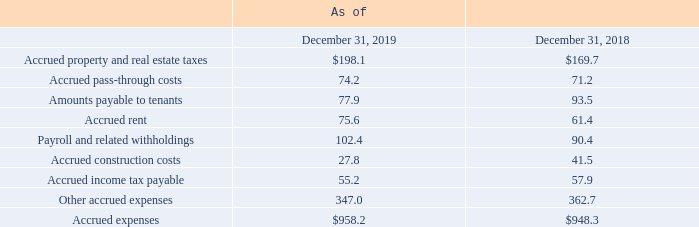AMERICAN TOWER CORPORATION AND SUBSIDIARIES NOTES TO CONSOLIDATED FINANCIAL STATEMENTS (Tabular amounts in millions, unless otherwise disclosed)
8. ACCRUED EXPENSES
Accrued expenses consisted of the following:
What was the Accrued property and real estate taxes in 2018?
Answer scale should be: million. $169.7. What was the Accrued pass-through costs in 2018?
Answer scale should be: million. 71.2. What were the Accrued expenses in 2019?
Answer scale should be: million. $958.2. What was the change in Other accrued expenses between 2018 and 2019?
Answer scale should be: million. 347.0-362.7
Answer: -15.7. What is the sum of the three highest expenses in 2019?
Answer scale should be: million. 198.1+102.4+ 347.0 
Answer: 647.5. What was the percentage change in accrued expenses between 2018 and 2019?
Answer scale should be: percent. ($958.2-$948.3)/$948.3
Answer: 1.04. 